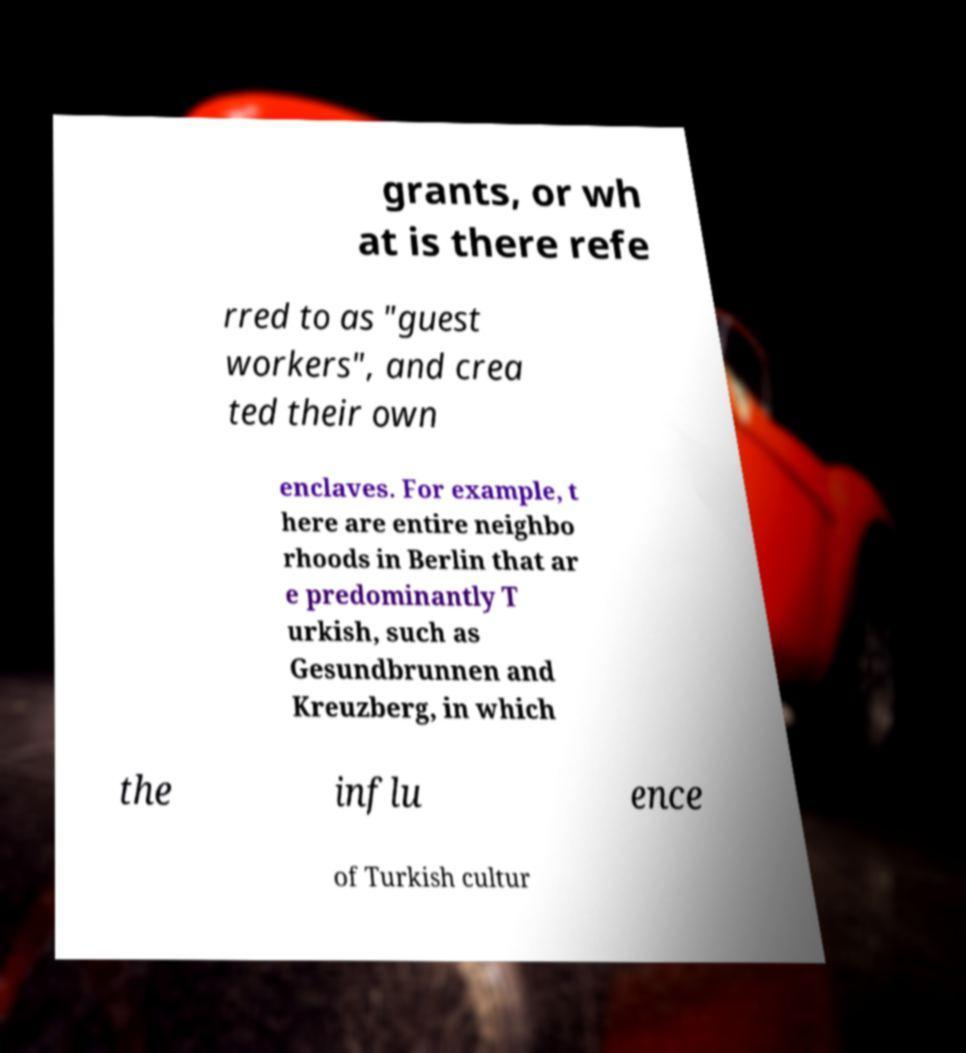Please identify and transcribe the text found in this image. grants, or wh at is there refe rred to as "guest workers", and crea ted their own enclaves. For example, t here are entire neighbo rhoods in Berlin that ar e predominantly T urkish, such as Gesundbrunnen and Kreuzberg, in which the influ ence of Turkish cultur 